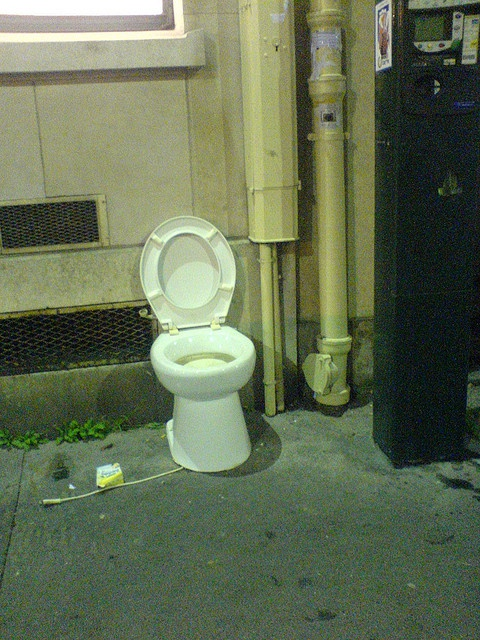Describe the objects in this image and their specific colors. I can see a toilet in white, darkgray, and beige tones in this image. 